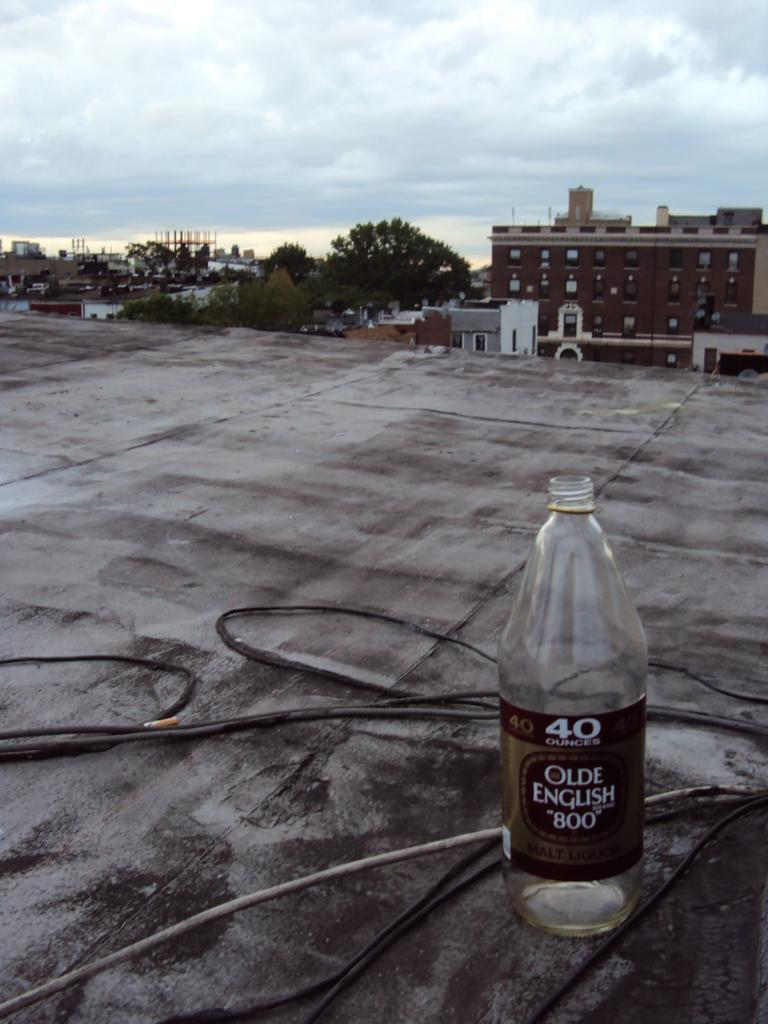What is the condition of the sky in the image? The sky is cloudy in the image. What type of natural vegetation can be seen in the image? There are trees in the image. What type of man-made structure is present in the image? There is a building in the image. What type of utility or communication infrastructure is visible in the image? There is a wire visible in the image. What type of object is present that might contain a liquid? There is a bottle in the image. What type of yard game is being played in the image? There is no yard game present in the image. What type of pipe is visible in the image? There is no pipe visible in the image. 